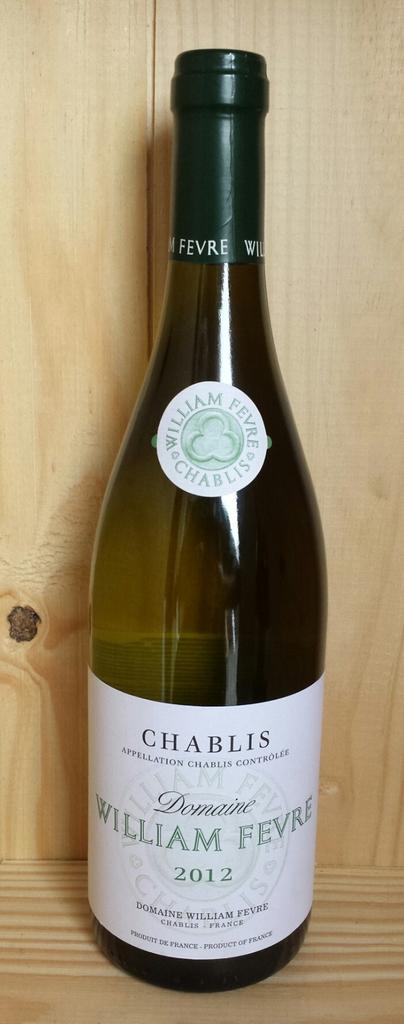What brand of wine is that?
Make the answer very short. Chablis. Chablis in this photo is from the year?
Your answer should be compact. 2012. 